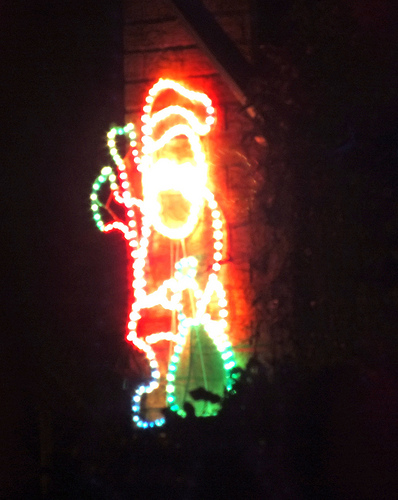<image>
Can you confirm if the santa is in the light? Yes. The santa is contained within or inside the light, showing a containment relationship. 